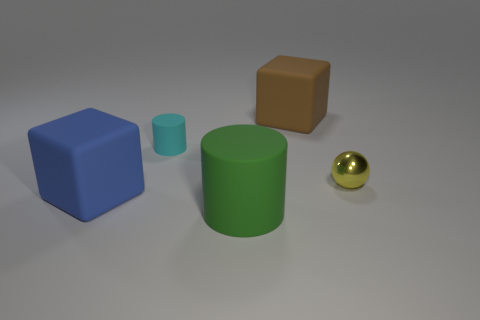Add 4 blue things. How many objects exist? 9 Subtract all blocks. How many objects are left? 3 Subtract 0 blue cylinders. How many objects are left? 5 Subtract all small green matte cylinders. Subtract all small yellow shiny things. How many objects are left? 4 Add 2 small cyan rubber cylinders. How many small cyan rubber cylinders are left? 3 Add 5 large metallic spheres. How many large metallic spheres exist? 5 